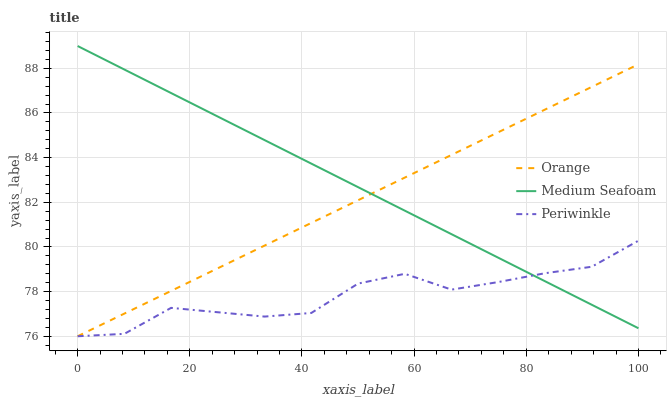Does Periwinkle have the minimum area under the curve?
Answer yes or no. Yes. Does Medium Seafoam have the maximum area under the curve?
Answer yes or no. Yes. Does Medium Seafoam have the minimum area under the curve?
Answer yes or no. No. Does Periwinkle have the maximum area under the curve?
Answer yes or no. No. Is Medium Seafoam the smoothest?
Answer yes or no. Yes. Is Periwinkle the roughest?
Answer yes or no. Yes. Is Periwinkle the smoothest?
Answer yes or no. No. Is Medium Seafoam the roughest?
Answer yes or no. No. Does Orange have the lowest value?
Answer yes or no. Yes. Does Medium Seafoam have the lowest value?
Answer yes or no. No. Does Medium Seafoam have the highest value?
Answer yes or no. Yes. Does Periwinkle have the highest value?
Answer yes or no. No. Does Orange intersect Medium Seafoam?
Answer yes or no. Yes. Is Orange less than Medium Seafoam?
Answer yes or no. No. Is Orange greater than Medium Seafoam?
Answer yes or no. No. 